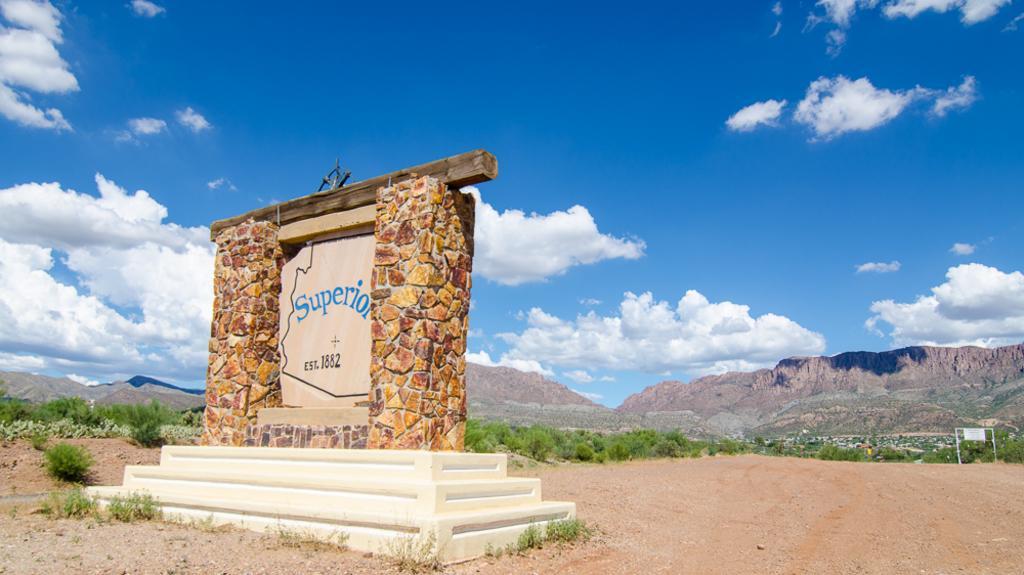Describe this image in one or two sentences. In the foreground I can see a memorial, grass, plants, trees and metal rods. In the background I can see houses, mountains and the sky. This image is taken may be during a day. 